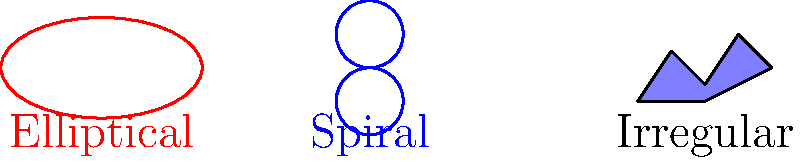In the context of distributing large-scale astronomical data using Elasticsearch, which type of galaxy represented in the diagram would likely require the most complex indexing strategy due to its diverse and unpredictable structure? To answer this question, let's consider each type of galaxy and its structure:

1. Elliptical Galaxy:
   - Simple, smooth structure
   - Relatively uniform distribution of stars
   - Can be easily described with a few parameters (e.g., size, eccentricity)

2. Spiral Galaxy:
   - More complex structure with spiral arms and a central bulge
   - Can be described with additional parameters (e.g., number of arms, arm tightness)
   - Still follows a predictable pattern

3. Irregular Galaxy:
   - No definite shape or structure
   - Highly diverse and unpredictable distribution of stars and other celestial objects
   - Difficult to describe with a standard set of parameters

When indexing astronomical data in Elasticsearch:
- Elliptical and spiral galaxies can be indexed using a relatively straightforward schema, as their structures follow predictable patterns.
- Irregular galaxies, however, present a challenge due to their lack of consistent structure.

For irregular galaxies, you might need:
- A more flexible schema to accommodate various structural features
- Additional fields to describe unique characteristics
- Potentially, nested objects or arrays to capture complex relationships between components

This complexity in indexing would likely require a more sophisticated Elastic4s client implementation, with custom mappings and possibly the use of percolate queries or script fields to effectively search and analyze the data.
Answer: Irregular galaxy 